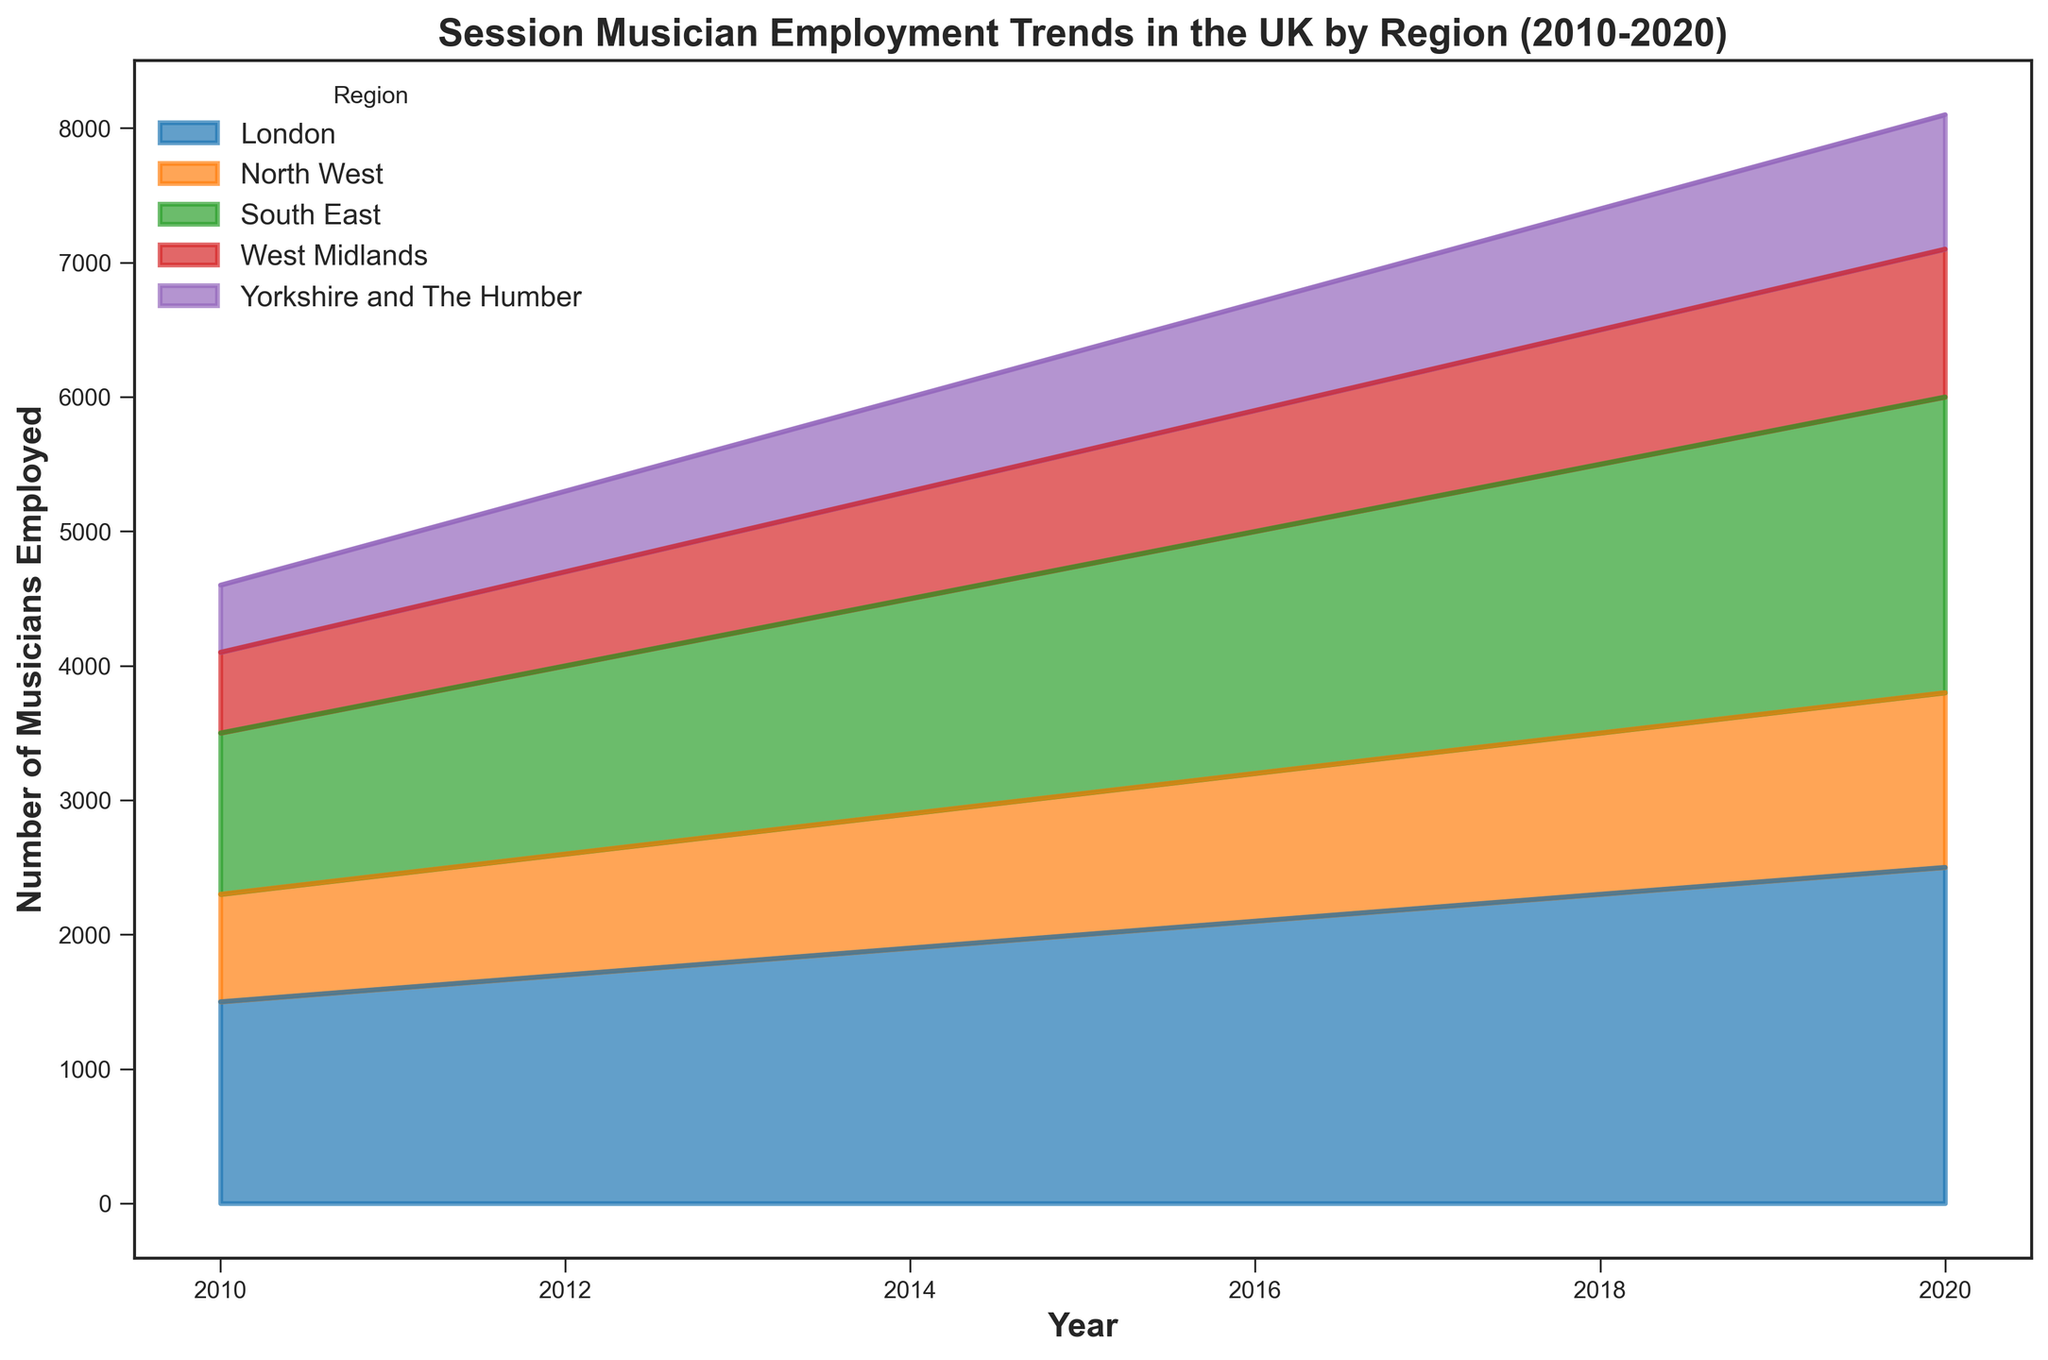What year did London have the highest number of employed musicians? To find the year with the highest number of employed musicians for London, look at the peak of the blue area representing London employment numbers. The highest peak corresponds to the year 2020.
Answer: 2020 Which region had the least number of employed musicians in 2010? Compare the areas representing each region at the year 2010; the smallest area corresponds to Yorkshire and The Humber.
Answer: Yorkshire and The Humber What is the overall trend in musician employment in London from 2010 to 2020? Observe the blue area representing London; it consistently increases from 2010 to 2020, indicating an upward trend.
Answer: Upward trend Did the number of musicians employed in the South East and North West ever equal each other between 2010 and 2020? Look for years when the orange area (South East) and green area (North West) overlap vertically. They never do, indicating their values were never equal.
Answer: No By how much did the musician employment numbers change in the West Midlands from 2015 to 2020? Note the height of the red area representing the West Midlands in 2015 (850) and 2020 (1100). The difference is 1100 - 850 = 250.
Answer: 250 What is the combined total of employed musicians in all regions in 2015? Sum the data points for all regions in 2015; London (2000), South East (1700), North West (1050), West Midlands (850), Yorkshire and The Humber (750). The total is 2000 + 1700 + 1050 + 850 + 750 = 6350.
Answer: 6350 Which region showed the most significant increase in musician employment from 2010 to 2020? Compare the increase in area for each region between 2010 and 2020; London has the most pronounced increase, growing from 1500 to 2500, a difference of 1000.
Answer: London How does the employment trend for musicians in Yorkshire and The Humber compare to that in the North West? While employment numbers in both regions increase over time, the green area (North West) consistently shows higher numbers than the purple area (Yorkshire and The Humber) from 2010 to 2020.
Answer: North West higher In which year was the total number of musicians employed in all regions the lowest? Examine the sum of all areas for each year and identify the smallest total area, which occurs in 2010.
Answer: 2010 How did the number of employed musicians in the South East change from 2010 to 2013? Observe the orange area representing the South East; it increases from 1200 in 2010 to 1500 in 2013.
Answer: Increase 